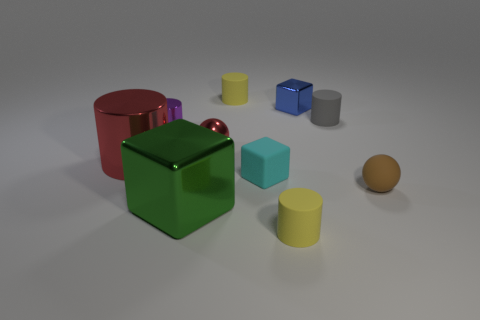What is the size of the ball that is the same color as the large shiny cylinder?
Your answer should be compact. Small. What material is the thing that is the same color as the metallic sphere?
Keep it short and to the point. Metal. There is a yellow thing that is in front of the brown rubber thing; does it have the same shape as the small blue metal object?
Provide a short and direct response. No. How many objects are either green matte objects or yellow rubber objects?
Offer a very short reply. 2. Do the big cylinder behind the cyan block and the green object have the same material?
Keep it short and to the point. Yes. The red metallic sphere is what size?
Your answer should be compact. Small. There is a object that is the same color as the tiny metallic ball; what shape is it?
Offer a terse response. Cylinder. What number of spheres are either small metal objects or matte objects?
Your answer should be compact. 2. Are there the same number of red metal objects behind the gray matte thing and spheres that are left of the brown object?
Make the answer very short. No. What is the size of the red metal object that is the same shape as the purple metallic thing?
Your answer should be very brief. Large. 